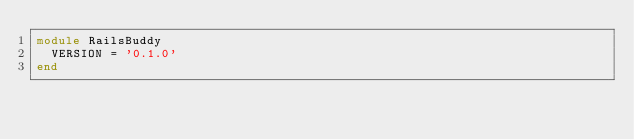Convert code to text. <code><loc_0><loc_0><loc_500><loc_500><_Ruby_>module RailsBuddy
  VERSION = '0.1.0'
end
</code> 